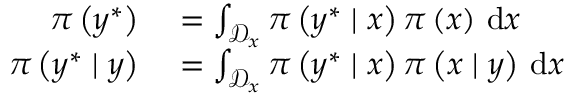Convert formula to latex. <formula><loc_0><loc_0><loc_500><loc_500>\begin{array} { r l } { \pi \left ( y ^ { \ast } \right ) } & = \int _ { \mathcal { D } _ { x } } \pi \left ( y ^ { \ast } | x \right ) \pi \left ( x \right ) \, d x } \\ { \pi \left ( y ^ { \ast } | y \right ) } & = \int _ { \mathcal { D } _ { x } } \pi \left ( y ^ { \ast } | x \right ) \pi \left ( x | y \right ) \, d x } \end{array}</formula> 